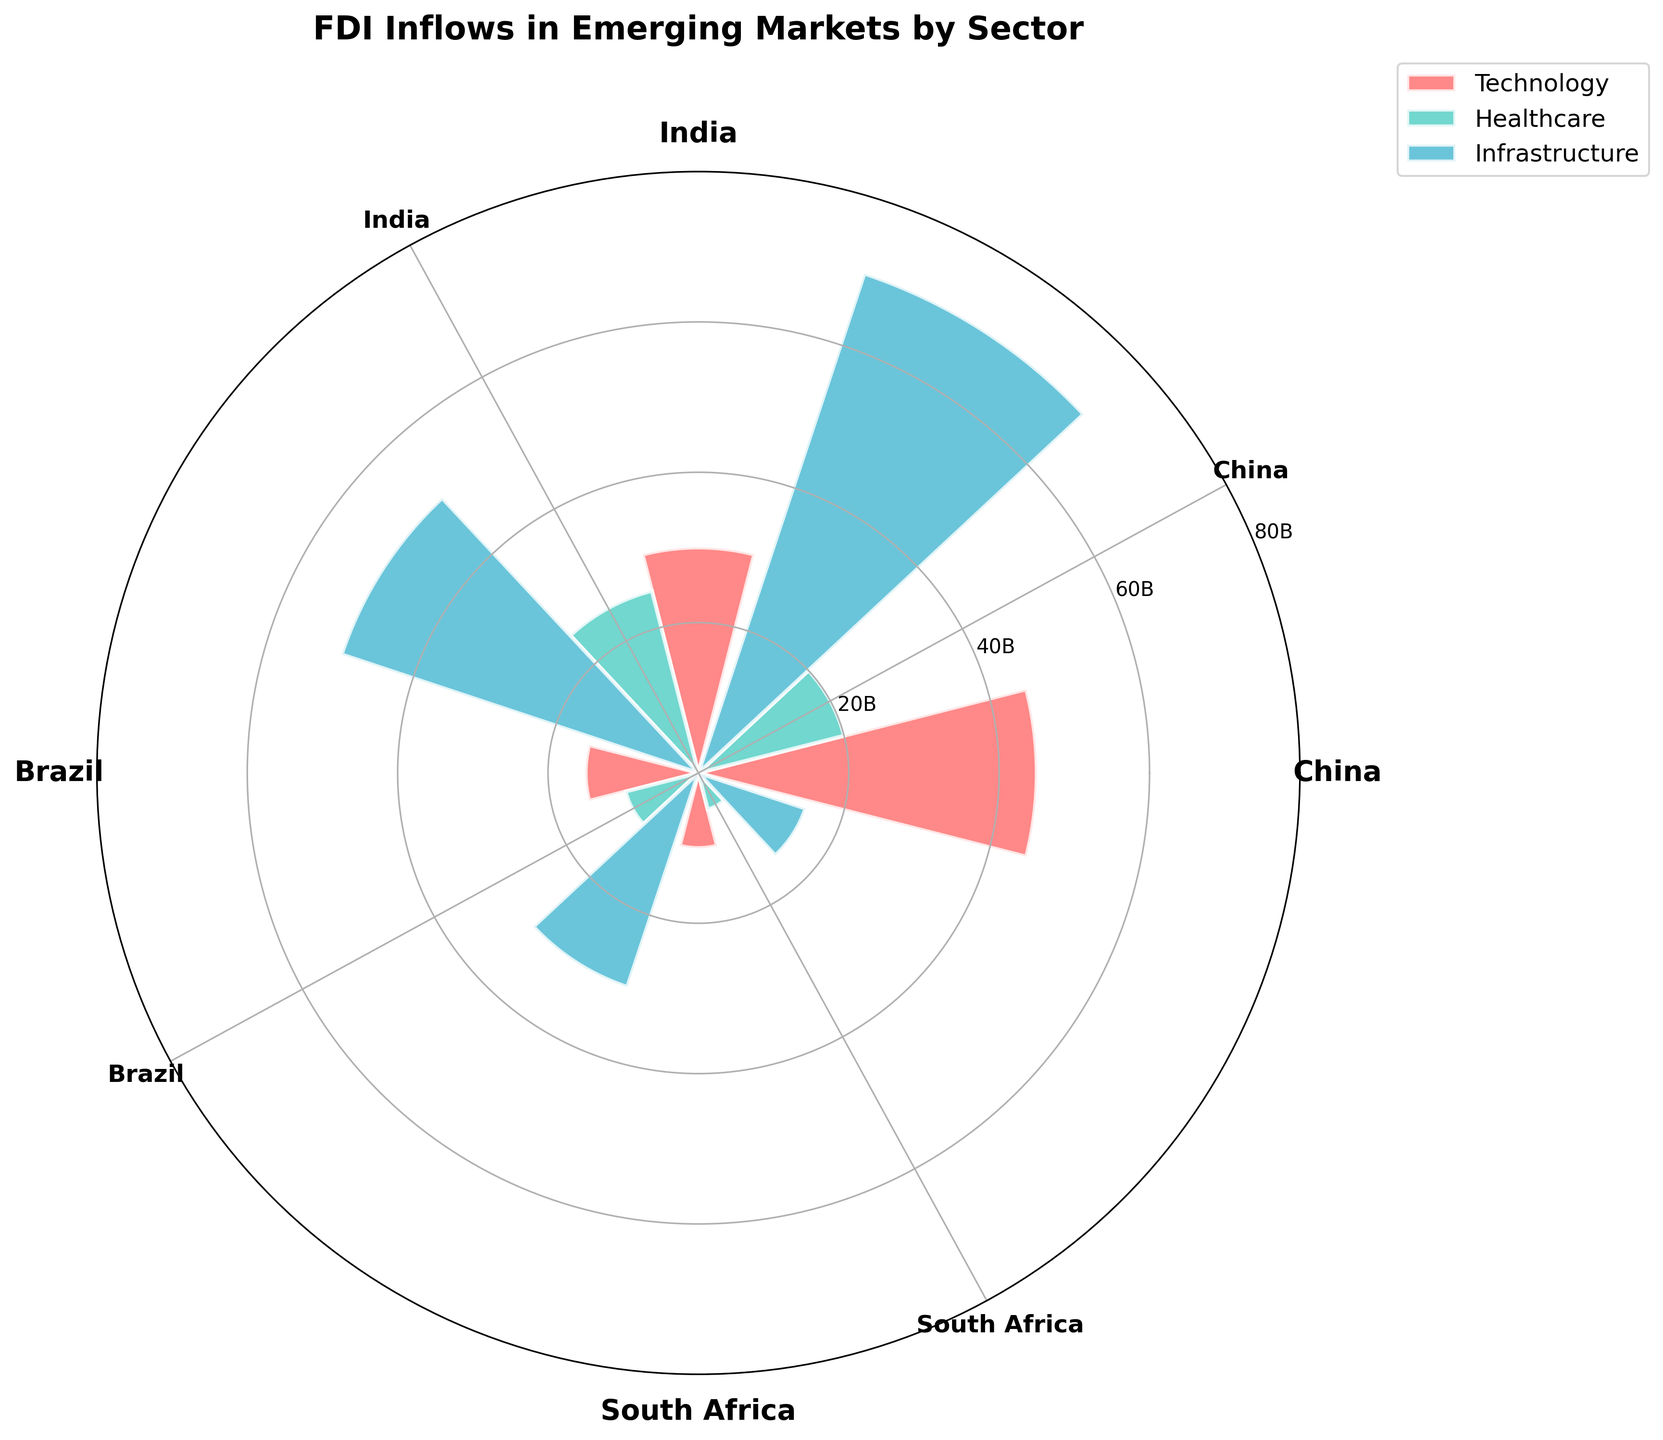How much was the FDI inflow in the Technology sector in China? The rose chart shows the FDI inflows in different sectors and countries. The bar corresponding to Technology and China is highlighted in the plot. Refer to the chart for exact numbers.
Answer: $45 billion Which sector had the highest FDI inflow in India? Look at the sectors within India and identify which bar extends the furthest from the center. The Infrastructure sector shows the largest value.
Answer: Infrastructure Between Technology and Healthcare, which sector received more FDI inflows in Brazil? Compare the lengths of the bars for Technology and Healthcare within Brazil. The longer bar indicates Technology received more.
Answer: Technology What is the total FDI inflow in South Africa across all sectors? Sum up the FDI inflow values shown for South Africa in each sector (Technology, Healthcare, and Infrastructure).
Answer: $30 billion Which country received the least foreign direct investment in the Healthcare sector? Observe the bars representing the Healthcare sector for each country and identify the shortest one, which corresponds to South Africa.
Answer: South Africa For China, what is the difference in FDI inflow between the Technology and Infrastructure sectors? Subtract the FDI inflows in Technology from those in Infrastructure for China (70 - 45).
Answer: $25 billion Is the FDI inflow in the Infrastructure sector in India greater than the sum of Technology and Healthcare sectors in Brazil? Compare the FDI inflow in Infrastructure in India ($50 billion) to the sum of Technology and Healthcare in Brazil (15 + 10 = $25 billion).
Answer: Yes How does the FDI inflow in Infrastructure in Brazil compare to that in South Africa? Compare the lengths of the bars for Infrastructure in Brazil and South Africa. Infrastructure in Brazil is longer.
Answer: Higher in Brazil What is the average FDI inflow across all sectors for India? Calculate the average by summing the FDI inflows for India across all sectors and dividing by the number of sectors (30 + 25 + 50)/3.
Answer: $35 billion 